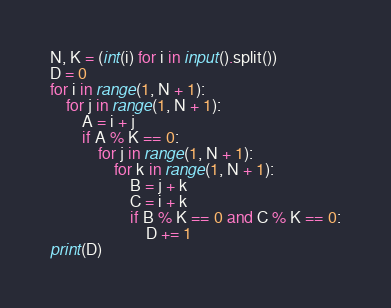<code> <loc_0><loc_0><loc_500><loc_500><_Python_>N, K = (int(i) for i in input().split())
D = 0
for i in range(1, N + 1):
    for j in range(1, N + 1):
        A = i + j
        if A % K == 0:
            for j in range(1, N + 1):
                for k in range(1, N + 1):
                    B = j + k
                    C = i + k
                    if B % K == 0 and C % K == 0:
                        D += 1
print(D)</code> 